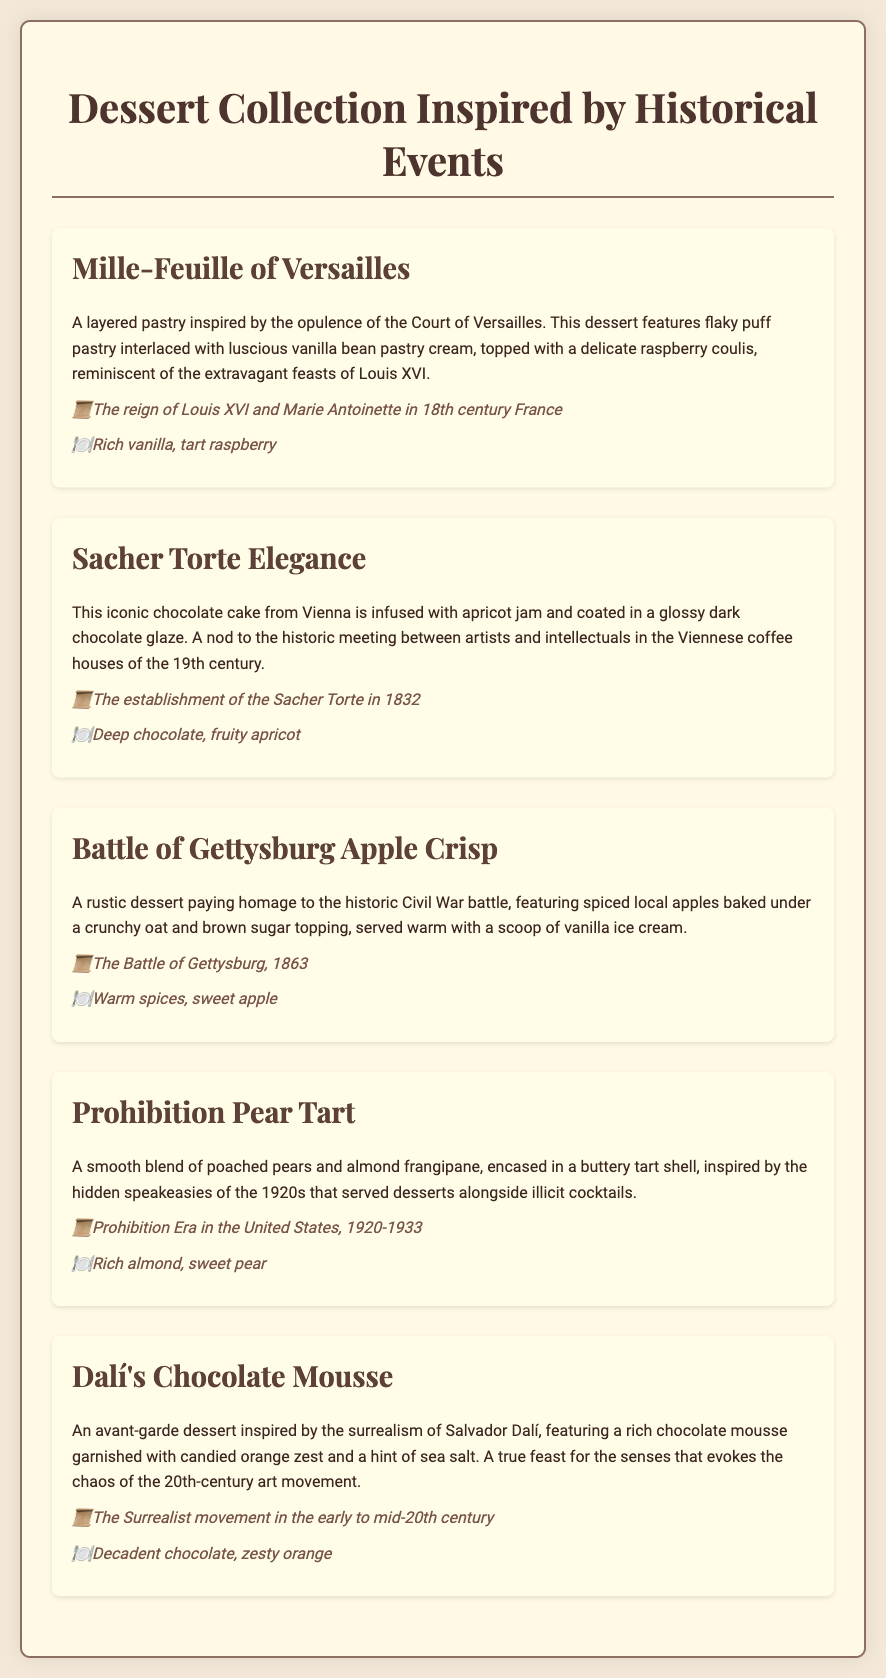What is the first dessert on the menu? The first dessert listed in the document is "Mille-Feuille of Versailles."
Answer: Mille-Feuille of Versailles What year was the Sacher Torte established? The document states that the Sacher Torte was established in 1832.
Answer: 1832 Which dessert is inspired by the 1920s Prohibition Era? The dessert inspired by the 1920s Prohibition Era is "Prohibition Pear Tart."
Answer: Prohibition Pear Tart What flavor profiles are associated with Dalí's Chocolate Mousse? The flavor profiles mentioned for Dalí's Chocolate Mousse are decadent chocolate and zesty orange.
Answer: Decadent chocolate, zesty orange Which historical event does the Battle of Gettysburg Apple Crisp reference? The Battle of Gettysburg Apple Crisp references the Battle of Gettysburg, which took place in 1863.
Answer: The Battle of Gettysburg, 1863 How many desserts are listed in the collection? The document lists a total of five desserts in the collection.
Answer: Five What is the flavor profile of the Mille-Feuille of Versailles? The flavor profile for the Mille-Feuille of Versailles includes rich vanilla and tart raspberry.
Answer: Rich vanilla, tart raspberry What fruit is featured in the Prohibition Pear Tart? The Prohibition Pear Tart features poached pears.
Answer: Poached pears 